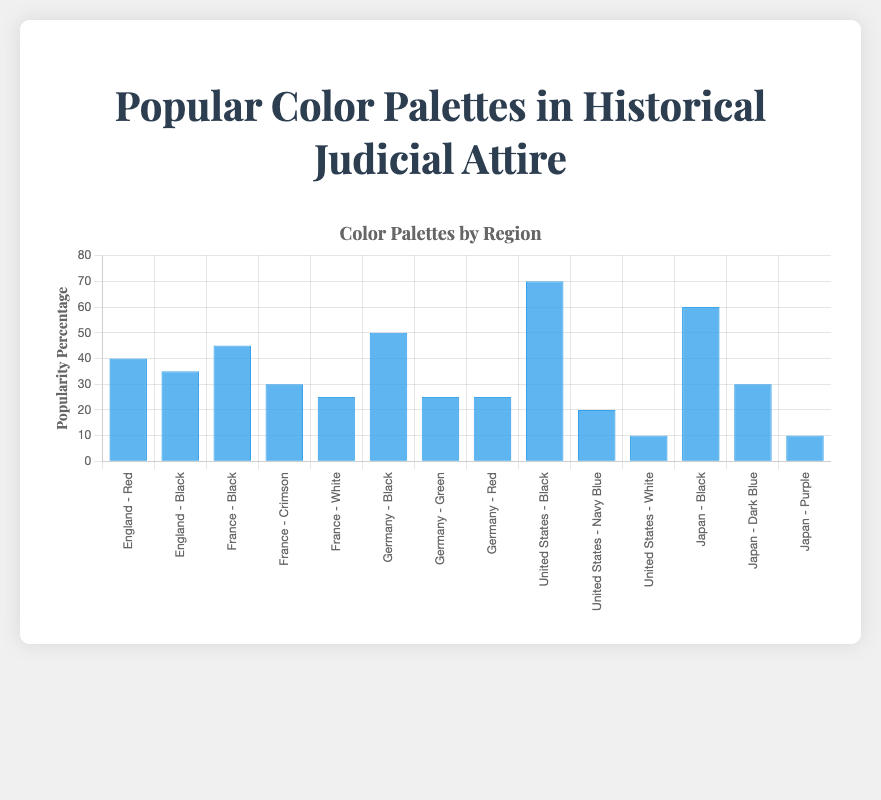Which region has the highest popularity percentage for black judicial attire? The United States has the highest popularity percentage for black judicial attire at 70%. This can be observed by noting the height of the bar labeled "United States - Black".
Answer: United States What is the average popularity percentage of red judicial attire across all regions? To find the average popularity percentage of red judicial attire, sum the percentages for England (40%), Germany (25%), and divide by the number of regions (2). (40% + 25%) / 2 = 32.5%
Answer: 32.5 Which color palette in Japan has the second highest popularity percentage? In Japan, the bars labeled "Black", "Dark Blue", and "Purple" have popularity percentages of 60%, 30%, and 10% respectively. The "Dark Blue" palette has the second highest value at 30%.
Answer: Dark Blue Does France have a higher percentage of black or white judicial attire? France has a higher percentage of black judicial attire (45%) compared to white judicial attire (25%). This can be confirmed by comparing the heights of the bars labeled "France - Black" and "France - White".
Answer: Black Which regions have a color palette with a popularity percentage of exactly 25%? The regions with a color palette that has a popularity percentage of 25% are France (White), Germany (Green and Red). This is observed from the heights of the bars labeled "France - White", "Germany - Green", and "Germany - Red".
Answer: France, Germany What is the combined popularity percentage of all color palettes in the United States? Sum the popularity percentages of all color palettes in the United States, which are Black (70%), Navy Blue (20%), and White (10%). 70% + 20% + 10% = 100%
Answer: 100 How does the popularity percentage of black judicial attire in Germany compare to Japan? Germany has a 50% popularity for black judicial attire, while Japan has 60%. Therefore, Japan has a higher percentage than Germany.
Answer: Japan Which color palette has the lowest overall popularity percentage in the dataset? The Purple palette in Japan has the lowest overall popularity percentage at 10%. This can be identified by locating the shortest bar in the chart.
Answer: Purple What is the difference in popularity percentage between the most popular and least popular color palettes in France? In France, the most popular color palette is Black with 45%, and the least popular is White with 25%. The difference is 45% - 25% = 20%.
Answer: 20 Calculate the average popularity percentage of all color palettes in England. Sum the popularity percentages of Red (40%) and Black (35%) in England and divide by the number of palettes (2). (40% + 35%) / 2 = 37.5%
Answer: 37.5 